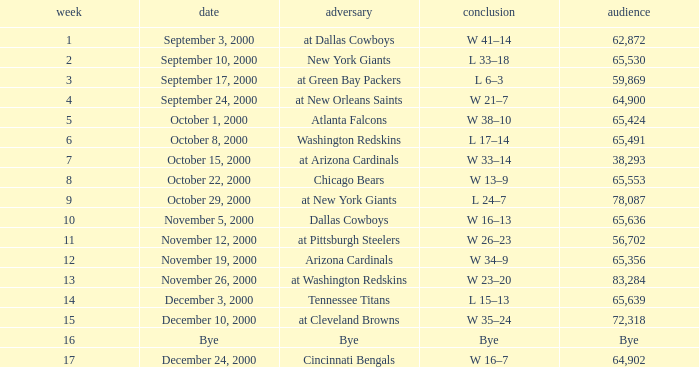Write the full table. {'header': ['week', 'date', 'adversary', 'conclusion', 'audience'], 'rows': [['1', 'September 3, 2000', 'at Dallas Cowboys', 'W 41–14', '62,872'], ['2', 'September 10, 2000', 'New York Giants', 'L 33–18', '65,530'], ['3', 'September 17, 2000', 'at Green Bay Packers', 'L 6–3', '59,869'], ['4', 'September 24, 2000', 'at New Orleans Saints', 'W 21–7', '64,900'], ['5', 'October 1, 2000', 'Atlanta Falcons', 'W 38–10', '65,424'], ['6', 'October 8, 2000', 'Washington Redskins', 'L 17–14', '65,491'], ['7', 'October 15, 2000', 'at Arizona Cardinals', 'W 33–14', '38,293'], ['8', 'October 22, 2000', 'Chicago Bears', 'W 13–9', '65,553'], ['9', 'October 29, 2000', 'at New York Giants', 'L 24–7', '78,087'], ['10', 'November 5, 2000', 'Dallas Cowboys', 'W 16–13', '65,636'], ['11', 'November 12, 2000', 'at Pittsburgh Steelers', 'W 26–23', '56,702'], ['12', 'November 19, 2000', 'Arizona Cardinals', 'W 34–9', '65,356'], ['13', 'November 26, 2000', 'at Washington Redskins', 'W 23–20', '83,284'], ['14', 'December 3, 2000', 'Tennessee Titans', 'L 15–13', '65,639'], ['15', 'December 10, 2000', 'at Cleveland Browns', 'W 35–24', '72,318'], ['16', 'Bye', 'Bye', 'Bye', 'Bye'], ['17', 'December 24, 2000', 'Cincinnati Bengals', 'W 16–7', '64,902']]} What was the attendance for week 2? 65530.0. 